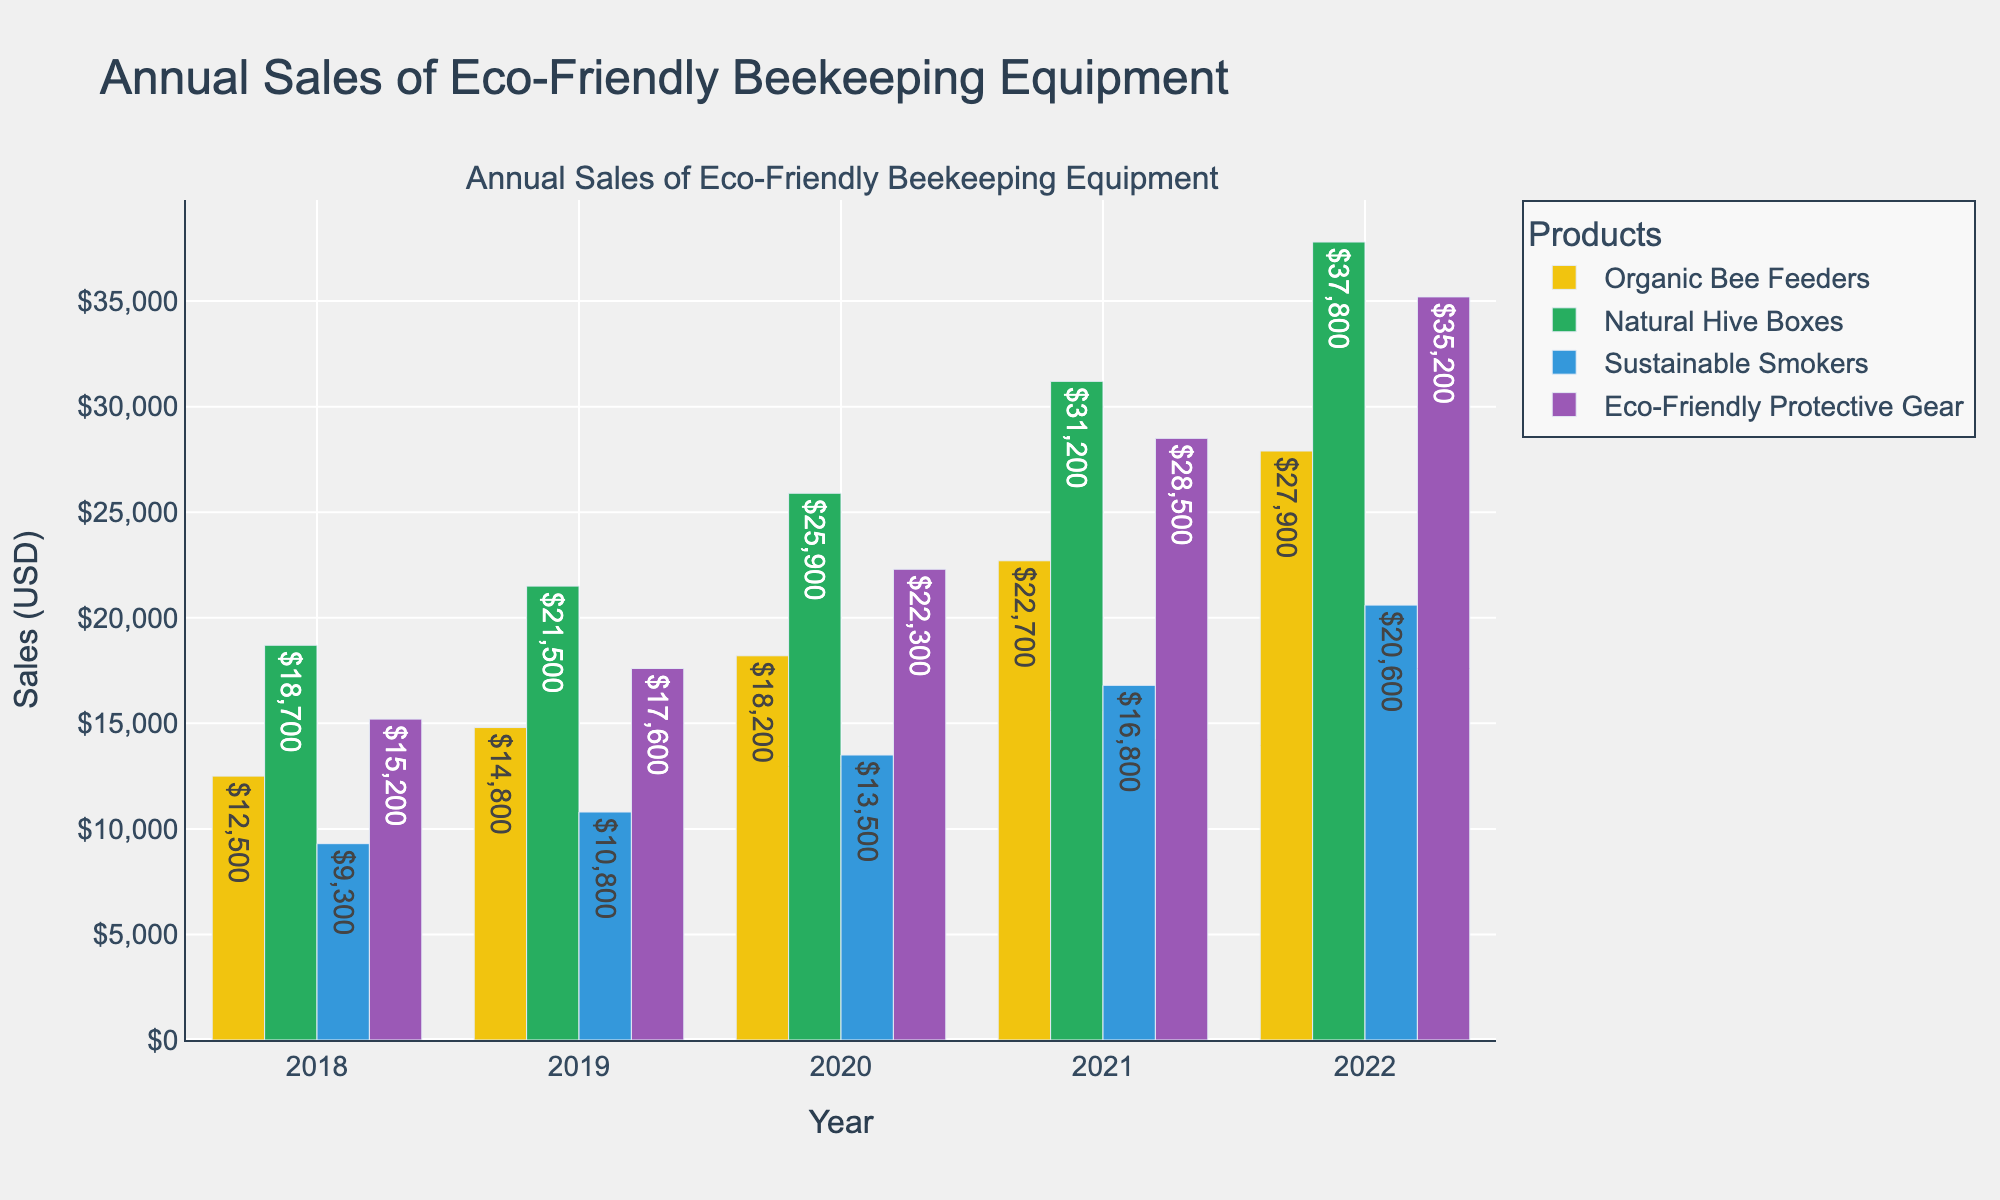Which product had the highest sales in 2022? Look at the bars for the year 2022 and compare the heights. Natural Hive Boxes had the highest bar, indicating the highest sales.
Answer: Natural Hive Boxes How did the sales of Organic Bee Feeders change from 2019 to 2020? Refer to the bar heights for Organic Bee Feeders in 2019 and 2020. The height is higher in 2020 compared to 2019, indicating an increase in sales. Calculate the difference: 18200 - 14800 = 3400 USD increase.
Answer: Increased by 3400 USD What is the total sales for Eco-Friendly Protective Gear over the years 2019 and 2020? Add the sales figures for Eco-Friendly Protective Gear in 2019 and 2020. Calculation: 17600 + 22300 = 39900 USD.
Answer: 39900 USD Which product had the smallest increase in sales from 2021 to 2022? Compare the difference in sales figures for each product between 2021 and 2022. The differences are: Organic Bee Feeders (27900 - 22700 = 5200), Natural Hive Boxes (37800 - 31200 = 6600), Sustainable Smokers (20600 - 16800 = 3800), Eco-Friendly Protective Gear (35200 - 28500 = 6700). The smallest increase is for Sustainable Smokers.
Answer: Sustainable Smokers How did the sales trends for Natural Hive Boxes change over the years 2018 to 2022? Observe the bar heights for Natural Hive Boxes from 2018 to 2022. The trend shows a continuous increase each year: 18700 (2018), 21500 (2019), 25900 (2020), 31200 (2021), 37800 (2022).
Answer: Continuous increase Is there any year where the sales for Sustainable Smokers decreased compared to the previous year? Compare the sales of Sustainable Smokers year by year: 2018 to 2019 (9300 to 10800 - increase), 2019 to 2020 (10800 to 13500 - increase), 2020 to 2021 (13500 to 16800 - increase), 2021 to 2022 (16800 to 20600 - increase). There is no year with a decrease.
Answer: No What was the difference in sales for Eco-Friendly Protective Gear between the highest and lowest years? Identify the highest (2022: 35200) and lowest (2018: 15200) sales years for Eco-Friendly Protective Gear and calculate the difference: 35200 - 15200 = 20000 USD.
Answer: 20000 USD Which product had sales more than 20000 USD in the year 2020? Look at the bars for 2020 and check the heights. Natural Hive Boxes had sales of 25900 USD, which is more than 20000 USD.
Answer: Natural Hive Boxes What was the percentage growth in sales of Natural Hive Boxes from 2018 to 2022? Calculate the sales growth percentage: (37800 - 18700) / 18700 * 100. Breaking down, sales increase is 37800 - 18700 = 19100 USD. Percent increase is (19100 / 18700) * 100 = ~102.14%.
Answer: ~102.14% 